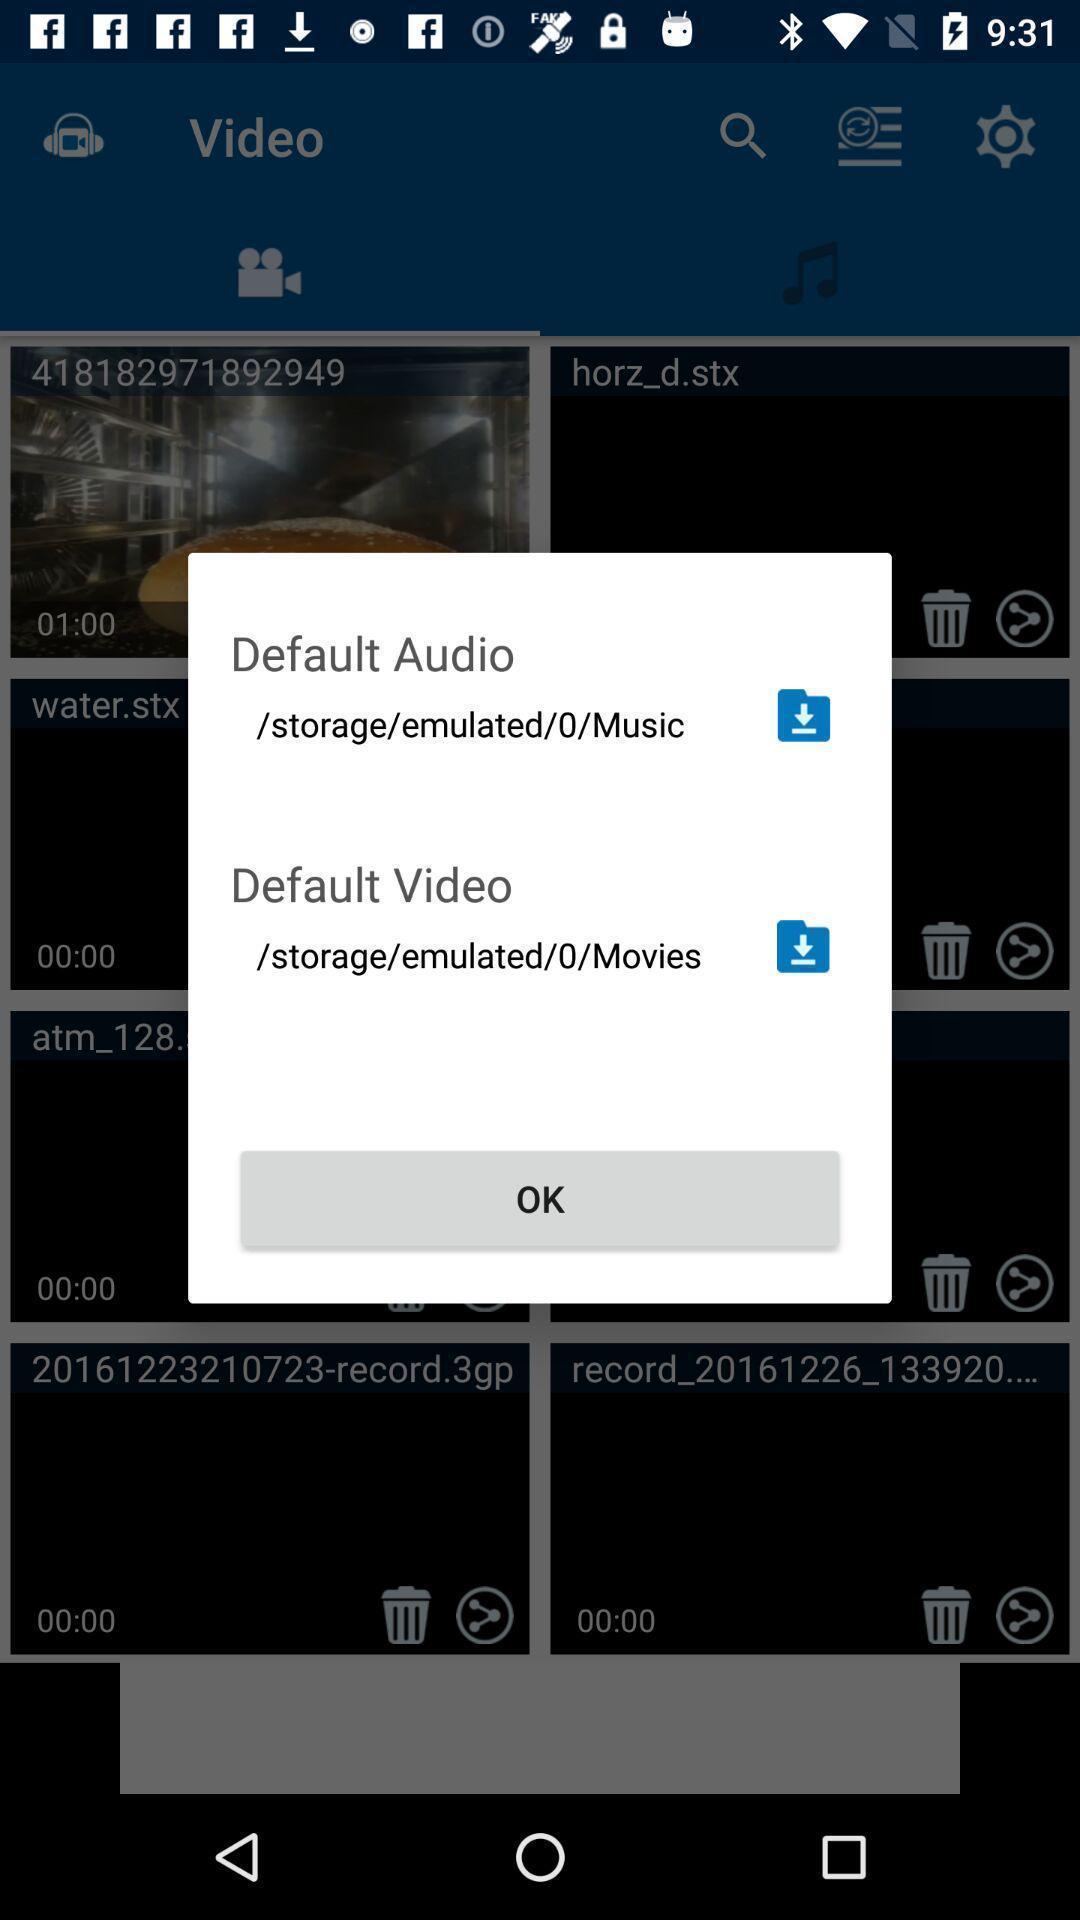Explain what's happening in this screen capture. Popup window showing storage for files. 